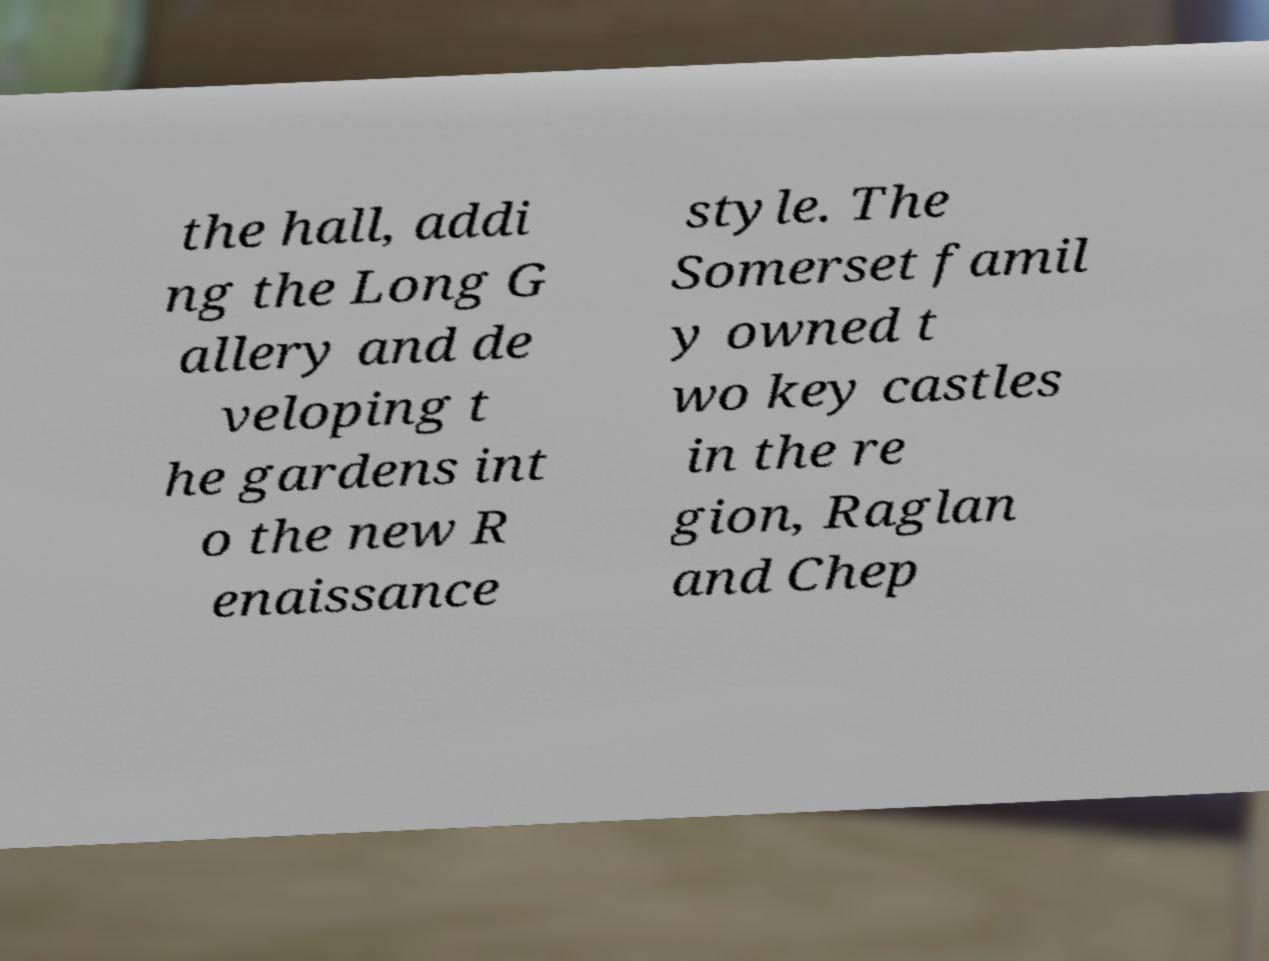Can you read and provide the text displayed in the image?This photo seems to have some interesting text. Can you extract and type it out for me? the hall, addi ng the Long G allery and de veloping t he gardens int o the new R enaissance style. The Somerset famil y owned t wo key castles in the re gion, Raglan and Chep 